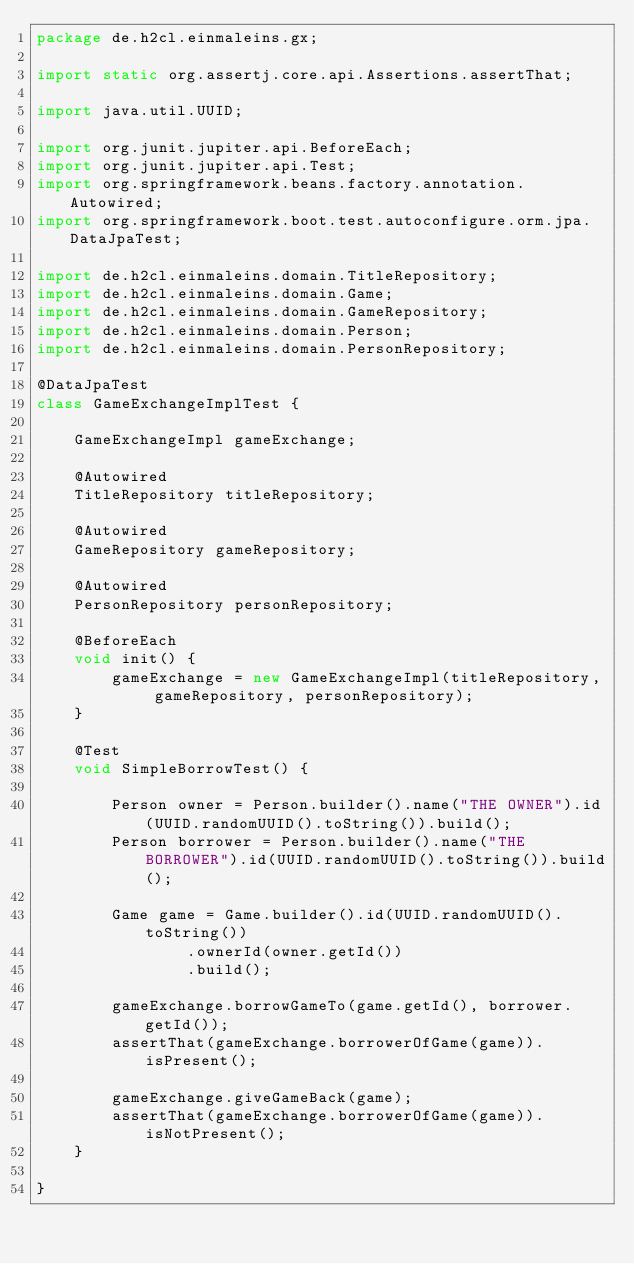<code> <loc_0><loc_0><loc_500><loc_500><_Java_>package de.h2cl.einmaleins.gx;

import static org.assertj.core.api.Assertions.assertThat;

import java.util.UUID;

import org.junit.jupiter.api.BeforeEach;
import org.junit.jupiter.api.Test;
import org.springframework.beans.factory.annotation.Autowired;
import org.springframework.boot.test.autoconfigure.orm.jpa.DataJpaTest;

import de.h2cl.einmaleins.domain.TitleRepository;
import de.h2cl.einmaleins.domain.Game;
import de.h2cl.einmaleins.domain.GameRepository;
import de.h2cl.einmaleins.domain.Person;
import de.h2cl.einmaleins.domain.PersonRepository;

@DataJpaTest
class GameExchangeImplTest {

    GameExchangeImpl gameExchange;

    @Autowired
    TitleRepository titleRepository;

    @Autowired
    GameRepository gameRepository;

    @Autowired
    PersonRepository personRepository;

    @BeforeEach
    void init() {
        gameExchange = new GameExchangeImpl(titleRepository, gameRepository, personRepository);
    }

    @Test
    void SimpleBorrowTest() {

        Person owner = Person.builder().name("THE OWNER").id(UUID.randomUUID().toString()).build();
        Person borrower = Person.builder().name("THE BORROWER").id(UUID.randomUUID().toString()).build();

        Game game = Game.builder().id(UUID.randomUUID().toString())
                .ownerId(owner.getId())
                .build();

        gameExchange.borrowGameTo(game.getId(), borrower.getId());
        assertThat(gameExchange.borrowerOfGame(game)).isPresent();

        gameExchange.giveGameBack(game);
        assertThat(gameExchange.borrowerOfGame(game)).isNotPresent();
    }

}</code> 